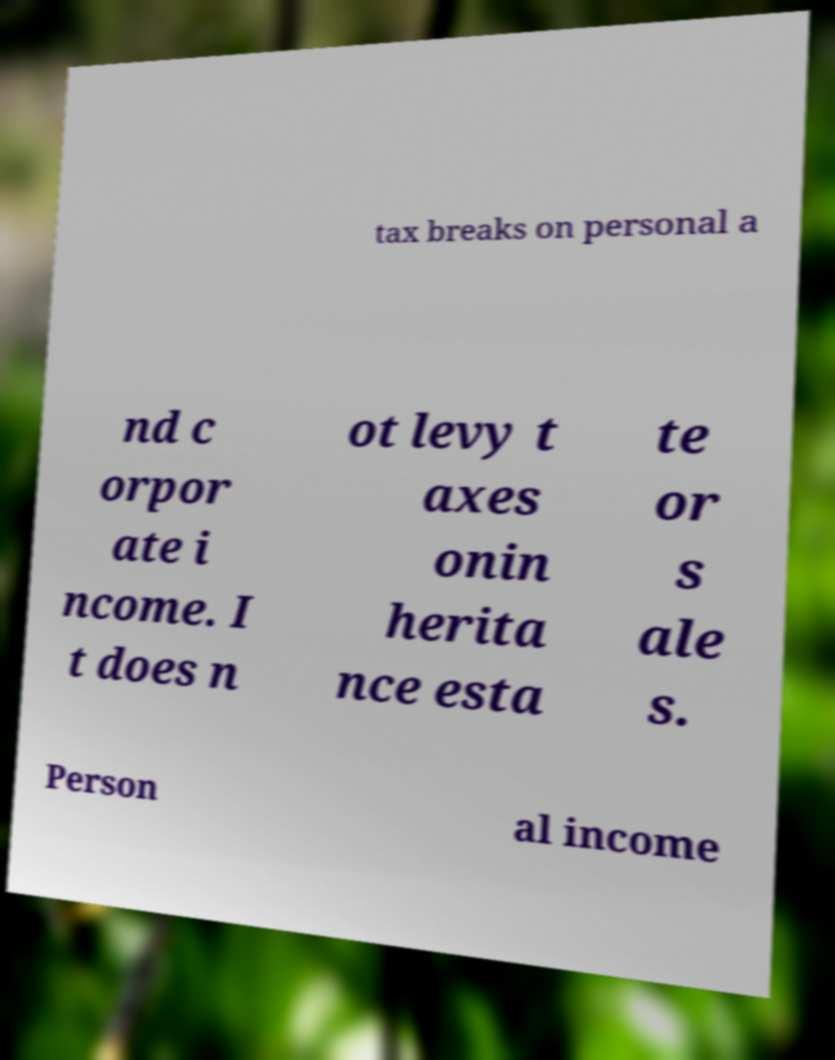Could you assist in decoding the text presented in this image and type it out clearly? tax breaks on personal a nd c orpor ate i ncome. I t does n ot levy t axes onin herita nce esta te or s ale s. Person al income 